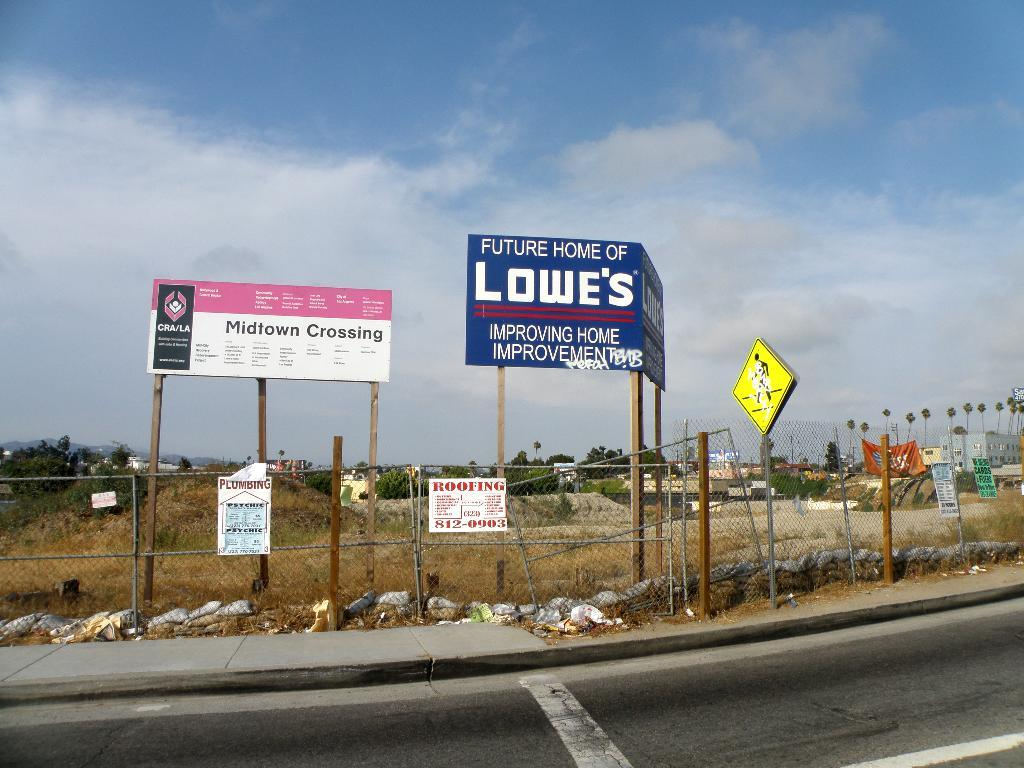<image>
Describe the image concisely. An empty lot with a metal fence and signs proclaiming that it is the Midtown Crossing and the future home of a Lowe's. 